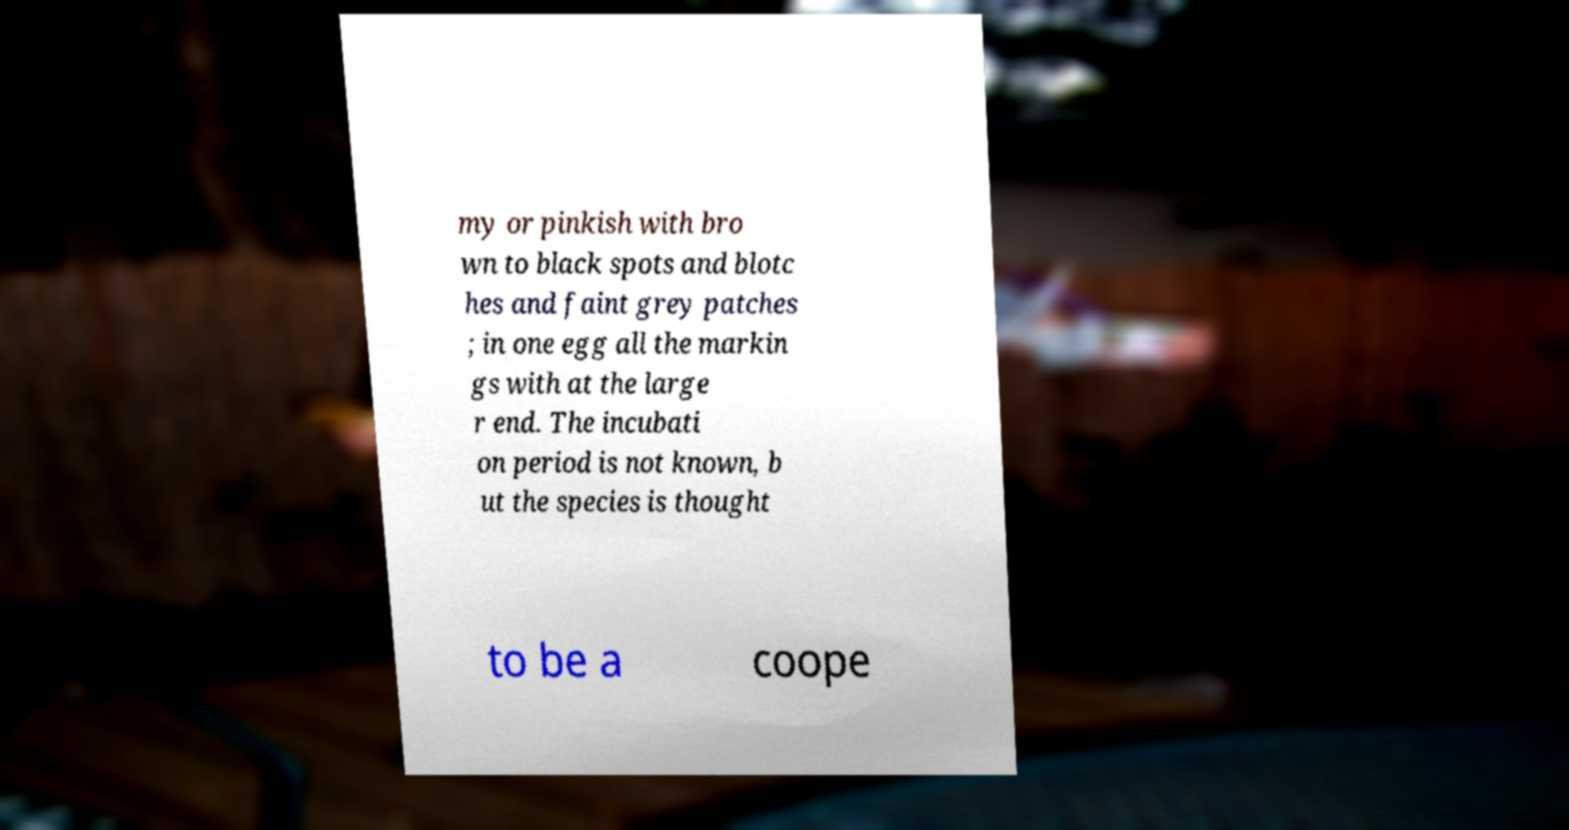There's text embedded in this image that I need extracted. Can you transcribe it verbatim? my or pinkish with bro wn to black spots and blotc hes and faint grey patches ; in one egg all the markin gs with at the large r end. The incubati on period is not known, b ut the species is thought to be a coope 